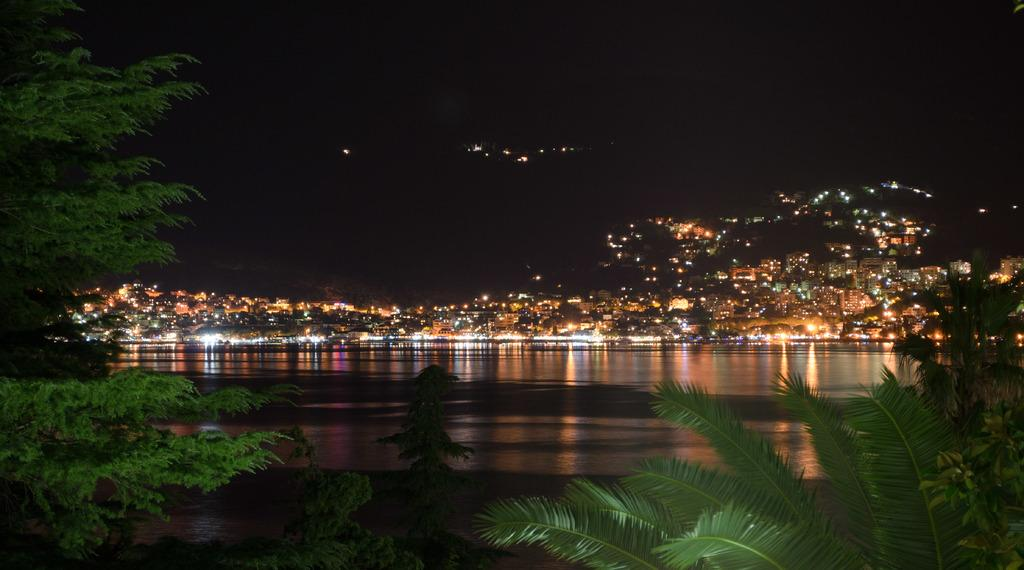What is the primary element visible in the image? There is water in the image. What can be seen behind the water? There are houses visible behind the water. Are the houses illuminated in any way? Yes, the houses have lighting. What other natural features can be seen in the image? There is a mountain visible in the image, as well as trees. What type of straw is being used to stop the love from growing in the image? There is no straw, love, or any indication of growth in the image. 